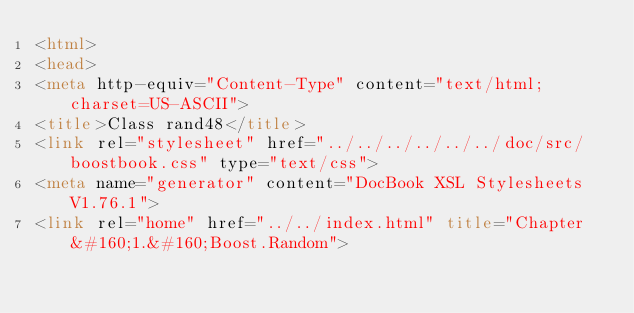Convert code to text. <code><loc_0><loc_0><loc_500><loc_500><_HTML_><html>
<head>
<meta http-equiv="Content-Type" content="text/html; charset=US-ASCII">
<title>Class rand48</title>
<link rel="stylesheet" href="../../../../../../doc/src/boostbook.css" type="text/css">
<meta name="generator" content="DocBook XSL Stylesheets V1.76.1">
<link rel="home" href="../../index.html" title="Chapter&#160;1.&#160;Boost.Random"></code> 